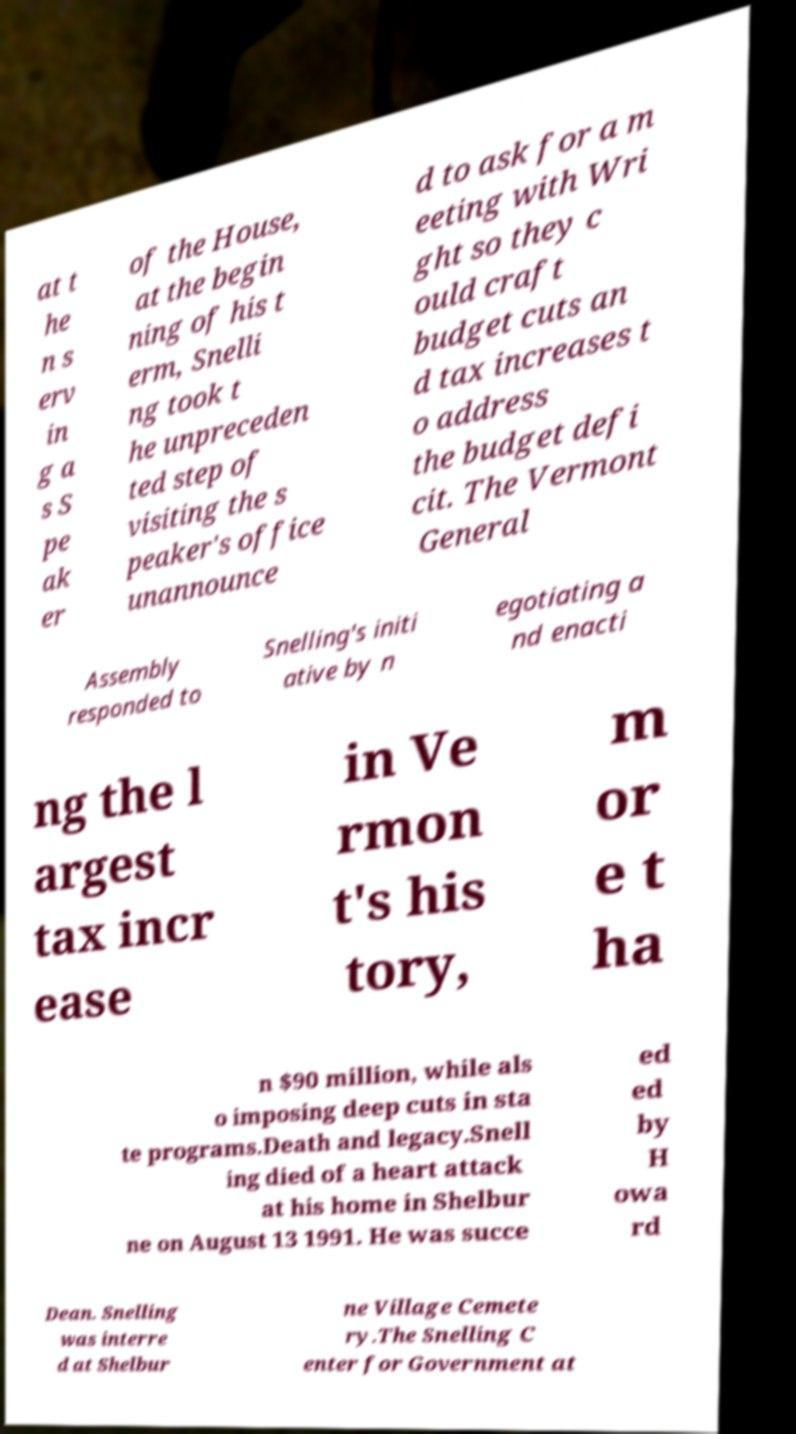Could you assist in decoding the text presented in this image and type it out clearly? at t he n s erv in g a s S pe ak er of the House, at the begin ning of his t erm, Snelli ng took t he unpreceden ted step of visiting the s peaker's office unannounce d to ask for a m eeting with Wri ght so they c ould craft budget cuts an d tax increases t o address the budget defi cit. The Vermont General Assembly responded to Snelling's initi ative by n egotiating a nd enacti ng the l argest tax incr ease in Ve rmon t's his tory, m or e t ha n $90 million, while als o imposing deep cuts in sta te programs.Death and legacy.Snell ing died of a heart attack at his home in Shelbur ne on August 13 1991. He was succe ed ed by H owa rd Dean. Snelling was interre d at Shelbur ne Village Cemete ry.The Snelling C enter for Government at 